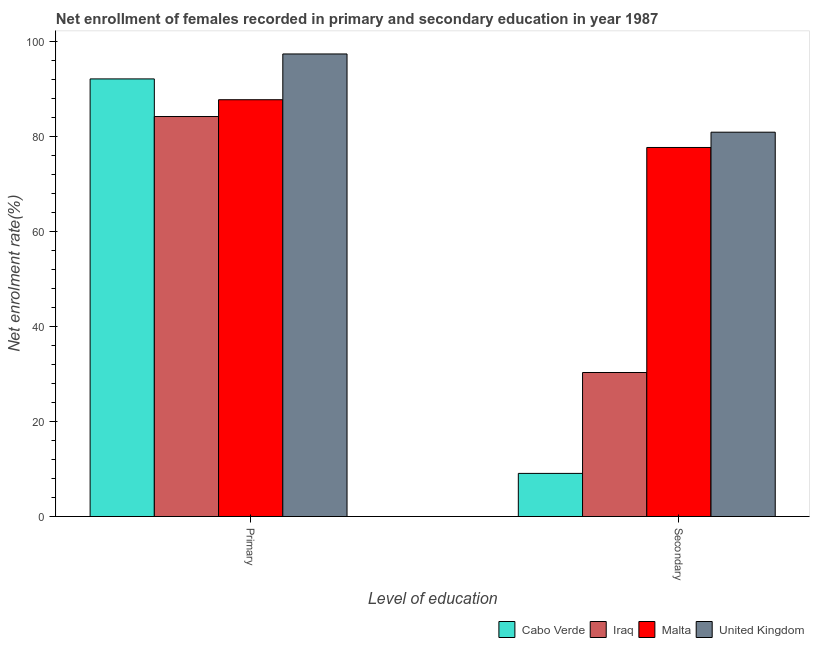How many different coloured bars are there?
Ensure brevity in your answer.  4. How many groups of bars are there?
Provide a succinct answer. 2. Are the number of bars per tick equal to the number of legend labels?
Offer a very short reply. Yes. Are the number of bars on each tick of the X-axis equal?
Provide a succinct answer. Yes. How many bars are there on the 2nd tick from the left?
Offer a very short reply. 4. How many bars are there on the 2nd tick from the right?
Provide a short and direct response. 4. What is the label of the 2nd group of bars from the left?
Keep it short and to the point. Secondary. What is the enrollment rate in secondary education in Cabo Verde?
Ensure brevity in your answer.  9.08. Across all countries, what is the maximum enrollment rate in primary education?
Offer a terse response. 97.44. Across all countries, what is the minimum enrollment rate in primary education?
Give a very brief answer. 84.26. In which country was the enrollment rate in secondary education minimum?
Your answer should be compact. Cabo Verde. What is the total enrollment rate in primary education in the graph?
Offer a very short reply. 361.67. What is the difference between the enrollment rate in primary education in United Kingdom and that in Malta?
Make the answer very short. 9.64. What is the difference between the enrollment rate in primary education in Iraq and the enrollment rate in secondary education in United Kingdom?
Give a very brief answer. 3.3. What is the average enrollment rate in primary education per country?
Keep it short and to the point. 90.42. What is the difference between the enrollment rate in primary education and enrollment rate in secondary education in Malta?
Provide a short and direct response. 10.06. In how many countries, is the enrollment rate in secondary education greater than 56 %?
Your response must be concise. 2. What is the ratio of the enrollment rate in secondary education in Iraq to that in Cabo Verde?
Ensure brevity in your answer.  3.34. Is the enrollment rate in primary education in Iraq less than that in Cabo Verde?
Ensure brevity in your answer.  Yes. Are all the bars in the graph horizontal?
Ensure brevity in your answer.  No. How many countries are there in the graph?
Offer a very short reply. 4. Are the values on the major ticks of Y-axis written in scientific E-notation?
Your answer should be compact. No. Does the graph contain any zero values?
Provide a short and direct response. No. How are the legend labels stacked?
Offer a very short reply. Horizontal. What is the title of the graph?
Offer a terse response. Net enrollment of females recorded in primary and secondary education in year 1987. What is the label or title of the X-axis?
Your answer should be very brief. Level of education. What is the label or title of the Y-axis?
Keep it short and to the point. Net enrolment rate(%). What is the Net enrolment rate(%) in Cabo Verde in Primary?
Provide a succinct answer. 92.18. What is the Net enrolment rate(%) in Iraq in Primary?
Your response must be concise. 84.26. What is the Net enrolment rate(%) in Malta in Primary?
Ensure brevity in your answer.  87.8. What is the Net enrolment rate(%) in United Kingdom in Primary?
Your response must be concise. 97.44. What is the Net enrolment rate(%) in Cabo Verde in Secondary?
Your answer should be very brief. 9.08. What is the Net enrolment rate(%) in Iraq in Secondary?
Your answer should be compact. 30.34. What is the Net enrolment rate(%) of Malta in Secondary?
Provide a short and direct response. 77.74. What is the Net enrolment rate(%) in United Kingdom in Secondary?
Provide a short and direct response. 80.96. Across all Level of education, what is the maximum Net enrolment rate(%) in Cabo Verde?
Your response must be concise. 92.18. Across all Level of education, what is the maximum Net enrolment rate(%) of Iraq?
Make the answer very short. 84.26. Across all Level of education, what is the maximum Net enrolment rate(%) of Malta?
Your answer should be compact. 87.8. Across all Level of education, what is the maximum Net enrolment rate(%) in United Kingdom?
Give a very brief answer. 97.44. Across all Level of education, what is the minimum Net enrolment rate(%) in Cabo Verde?
Offer a very short reply. 9.08. Across all Level of education, what is the minimum Net enrolment rate(%) in Iraq?
Offer a very short reply. 30.34. Across all Level of education, what is the minimum Net enrolment rate(%) in Malta?
Provide a succinct answer. 77.74. Across all Level of education, what is the minimum Net enrolment rate(%) in United Kingdom?
Offer a terse response. 80.96. What is the total Net enrolment rate(%) of Cabo Verde in the graph?
Ensure brevity in your answer.  101.26. What is the total Net enrolment rate(%) of Iraq in the graph?
Offer a terse response. 114.59. What is the total Net enrolment rate(%) of Malta in the graph?
Provide a short and direct response. 165.54. What is the total Net enrolment rate(%) of United Kingdom in the graph?
Offer a terse response. 178.39. What is the difference between the Net enrolment rate(%) in Cabo Verde in Primary and that in Secondary?
Your answer should be compact. 83.1. What is the difference between the Net enrolment rate(%) of Iraq in Primary and that in Secondary?
Provide a succinct answer. 53.92. What is the difference between the Net enrolment rate(%) in Malta in Primary and that in Secondary?
Offer a very short reply. 10.06. What is the difference between the Net enrolment rate(%) of United Kingdom in Primary and that in Secondary?
Provide a succinct answer. 16.48. What is the difference between the Net enrolment rate(%) of Cabo Verde in Primary and the Net enrolment rate(%) of Iraq in Secondary?
Keep it short and to the point. 61.84. What is the difference between the Net enrolment rate(%) of Cabo Verde in Primary and the Net enrolment rate(%) of Malta in Secondary?
Offer a terse response. 14.44. What is the difference between the Net enrolment rate(%) in Cabo Verde in Primary and the Net enrolment rate(%) in United Kingdom in Secondary?
Your response must be concise. 11.22. What is the difference between the Net enrolment rate(%) of Iraq in Primary and the Net enrolment rate(%) of Malta in Secondary?
Give a very brief answer. 6.52. What is the difference between the Net enrolment rate(%) of Iraq in Primary and the Net enrolment rate(%) of United Kingdom in Secondary?
Your answer should be very brief. 3.3. What is the difference between the Net enrolment rate(%) of Malta in Primary and the Net enrolment rate(%) of United Kingdom in Secondary?
Give a very brief answer. 6.84. What is the average Net enrolment rate(%) of Cabo Verde per Level of education?
Keep it short and to the point. 50.63. What is the average Net enrolment rate(%) of Iraq per Level of education?
Make the answer very short. 57.3. What is the average Net enrolment rate(%) of Malta per Level of education?
Your answer should be very brief. 82.77. What is the average Net enrolment rate(%) of United Kingdom per Level of education?
Make the answer very short. 89.2. What is the difference between the Net enrolment rate(%) in Cabo Verde and Net enrolment rate(%) in Iraq in Primary?
Make the answer very short. 7.92. What is the difference between the Net enrolment rate(%) in Cabo Verde and Net enrolment rate(%) in Malta in Primary?
Provide a succinct answer. 4.38. What is the difference between the Net enrolment rate(%) in Cabo Verde and Net enrolment rate(%) in United Kingdom in Primary?
Your response must be concise. -5.26. What is the difference between the Net enrolment rate(%) of Iraq and Net enrolment rate(%) of Malta in Primary?
Ensure brevity in your answer.  -3.54. What is the difference between the Net enrolment rate(%) of Iraq and Net enrolment rate(%) of United Kingdom in Primary?
Give a very brief answer. -13.18. What is the difference between the Net enrolment rate(%) of Malta and Net enrolment rate(%) of United Kingdom in Primary?
Provide a short and direct response. -9.64. What is the difference between the Net enrolment rate(%) of Cabo Verde and Net enrolment rate(%) of Iraq in Secondary?
Offer a very short reply. -21.25. What is the difference between the Net enrolment rate(%) in Cabo Verde and Net enrolment rate(%) in Malta in Secondary?
Ensure brevity in your answer.  -68.66. What is the difference between the Net enrolment rate(%) in Cabo Verde and Net enrolment rate(%) in United Kingdom in Secondary?
Offer a very short reply. -71.87. What is the difference between the Net enrolment rate(%) in Iraq and Net enrolment rate(%) in Malta in Secondary?
Offer a terse response. -47.4. What is the difference between the Net enrolment rate(%) of Iraq and Net enrolment rate(%) of United Kingdom in Secondary?
Provide a succinct answer. -50.62. What is the difference between the Net enrolment rate(%) of Malta and Net enrolment rate(%) of United Kingdom in Secondary?
Your response must be concise. -3.22. What is the ratio of the Net enrolment rate(%) of Cabo Verde in Primary to that in Secondary?
Make the answer very short. 10.15. What is the ratio of the Net enrolment rate(%) of Iraq in Primary to that in Secondary?
Provide a short and direct response. 2.78. What is the ratio of the Net enrolment rate(%) in Malta in Primary to that in Secondary?
Provide a succinct answer. 1.13. What is the ratio of the Net enrolment rate(%) of United Kingdom in Primary to that in Secondary?
Offer a terse response. 1.2. What is the difference between the highest and the second highest Net enrolment rate(%) in Cabo Verde?
Offer a very short reply. 83.1. What is the difference between the highest and the second highest Net enrolment rate(%) in Iraq?
Provide a succinct answer. 53.92. What is the difference between the highest and the second highest Net enrolment rate(%) of Malta?
Make the answer very short. 10.06. What is the difference between the highest and the second highest Net enrolment rate(%) in United Kingdom?
Your response must be concise. 16.48. What is the difference between the highest and the lowest Net enrolment rate(%) in Cabo Verde?
Give a very brief answer. 83.1. What is the difference between the highest and the lowest Net enrolment rate(%) in Iraq?
Keep it short and to the point. 53.92. What is the difference between the highest and the lowest Net enrolment rate(%) of Malta?
Ensure brevity in your answer.  10.06. What is the difference between the highest and the lowest Net enrolment rate(%) in United Kingdom?
Provide a short and direct response. 16.48. 